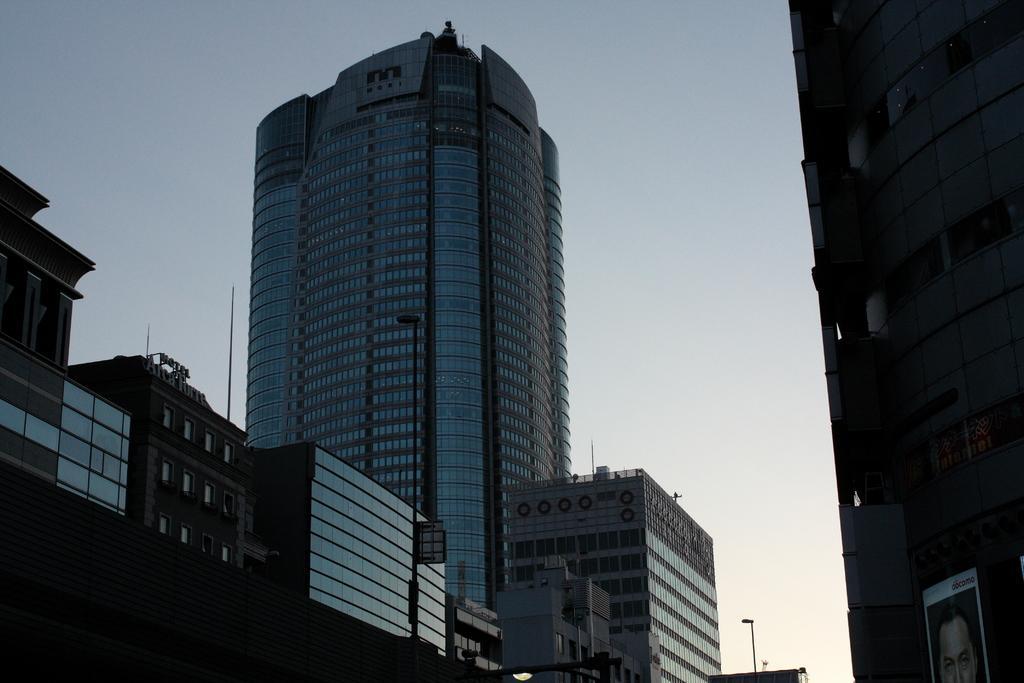In one or two sentences, can you explain what this image depicts? This is a skyscraper and the buildings with glass doors. This is the name board, which is at the top of the building. This looks like a poster. I think these are the streetlights. 